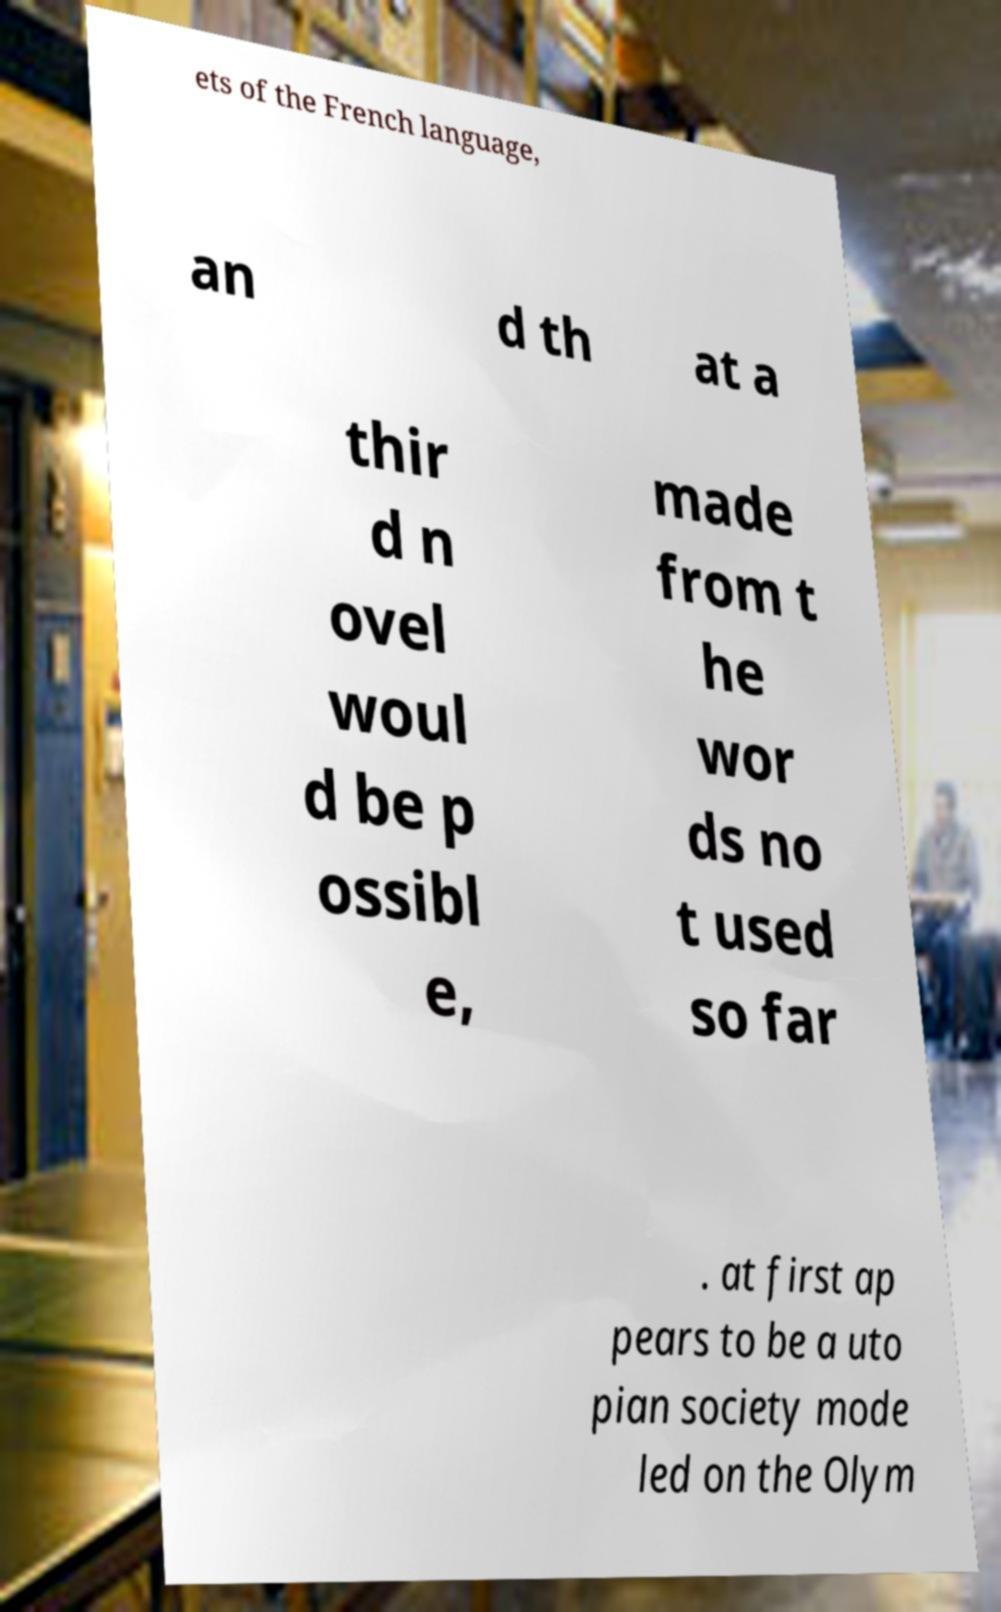For documentation purposes, I need the text within this image transcribed. Could you provide that? ets of the French language, an d th at a thir d n ovel woul d be p ossibl e, made from t he wor ds no t used so far . at first ap pears to be a uto pian society mode led on the Olym 